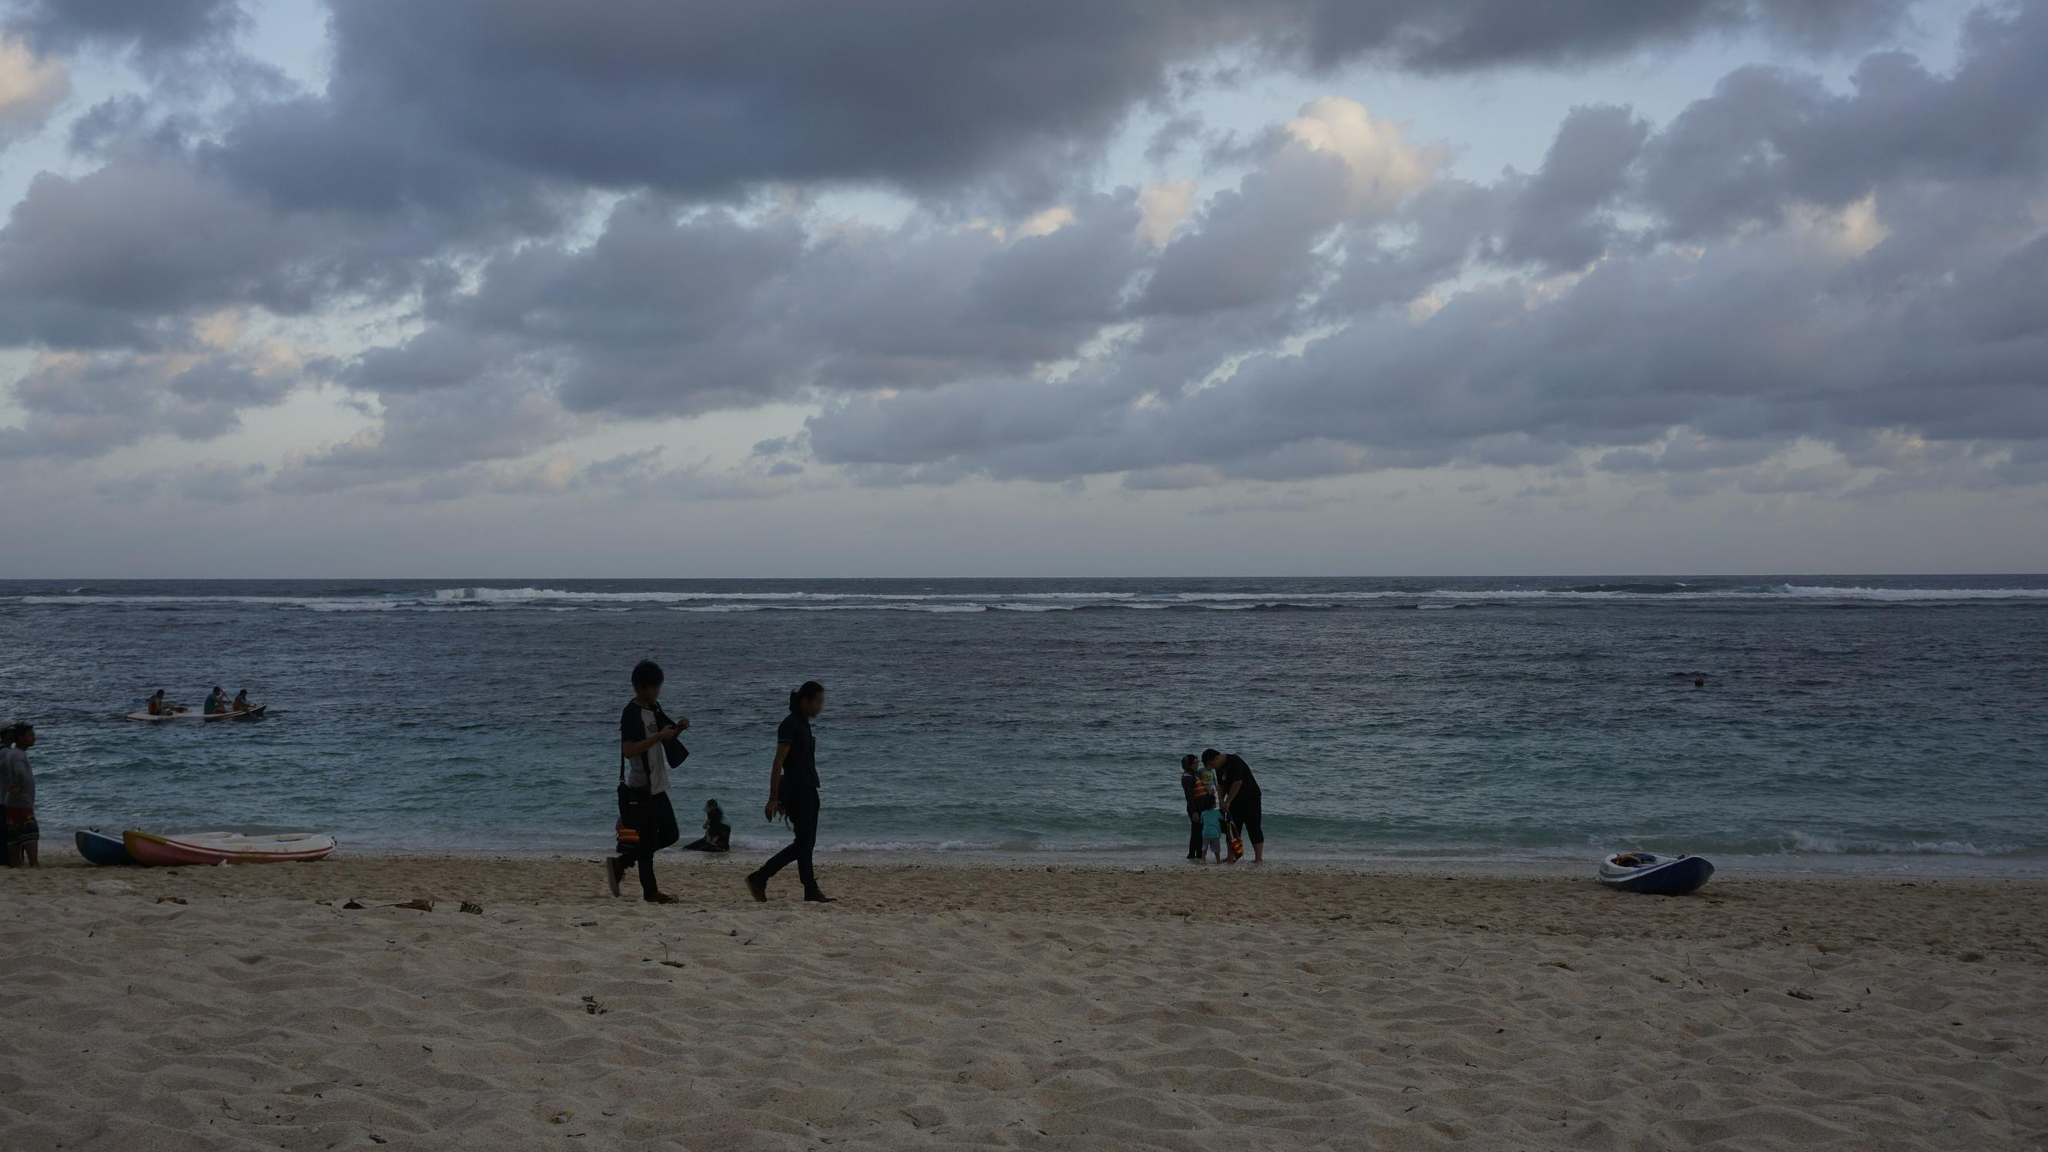Imagine how this beach might look in the peak of summer. In the peak of summer, this beach would likely be bustling with even more activity. The sandy shore would be dotted with colorful umbrellas and blankets as families and friends gather to enjoy the sunny weather. Children would be seen building sandcastles, playing frisbee, and splashing at the water's edge. The ocean would be filled with swimmers, surfers catching waves, and perhaps even boats and jet skis zipping across the water.

The atmosphere would be lively, with laughter and the sound of waves creating a cheerful background. Beach vendors might be present, selling ice cream, cold drinks, and snacks, adding to the vibrant ambiance. Despite the increased activity, the beach's natural beauty would still shine through with the clear blue sky above, the sparkling ocean, and the soft, warm sand. Do you think this beach could be a good place for a sunset photo session? Why or why not? Absolutely, this beach could be an excellent location for a sunset photo session. The expanse of the ocean provides a perfect, unobstructed view of the horizon, where the sun would dip below, casting a golden hue over everything. The cloud formations could add texture and drama to the sky, making the colors of the sunset even more striking. The reflective nature of the water's surface would enhance this effect, creating beautiful, shimmering reflections.

Additionally, the beach's relatively quiet and serene atmosphere, as seen in the image, suggests it could provide a peaceful setting for capturing the sunset without too many interruptions. The natural elements, such as the sandy shore and the gentle waves, provide fantastic foreground and background elements that can make the photographs more dynamic and appealing. Why do you think people are attracted to beaches in general? People are often drawn to beaches for a variety of reasons. The natural beauty and calming effect of the ocean and the sound of waves can be incredibly relaxing and therapeutic. Beaches offer a sense of escape from the hustle and bustle of daily life, providing a tranquil environment to unwind and de-stress.

The wide range of recreational activities available at the beach, such as swimming, sunbathing, playing sports, and enjoying water sports, make it a versatile destination that's appealing to people of all ages. Additionally, beaches provide an opportunity to connect with nature, whether it's through exploring marine life, collecting seashells, or simply enjoying a walk along the shore.

For many, beaches also hold memories of vacations and happy times spent with family and friends, which adds to their overall appeal. The combination of natural beauty, recreational opportunities, and the peaceful ambiance make beaches a favorite destination for relaxation and enjoyment. 